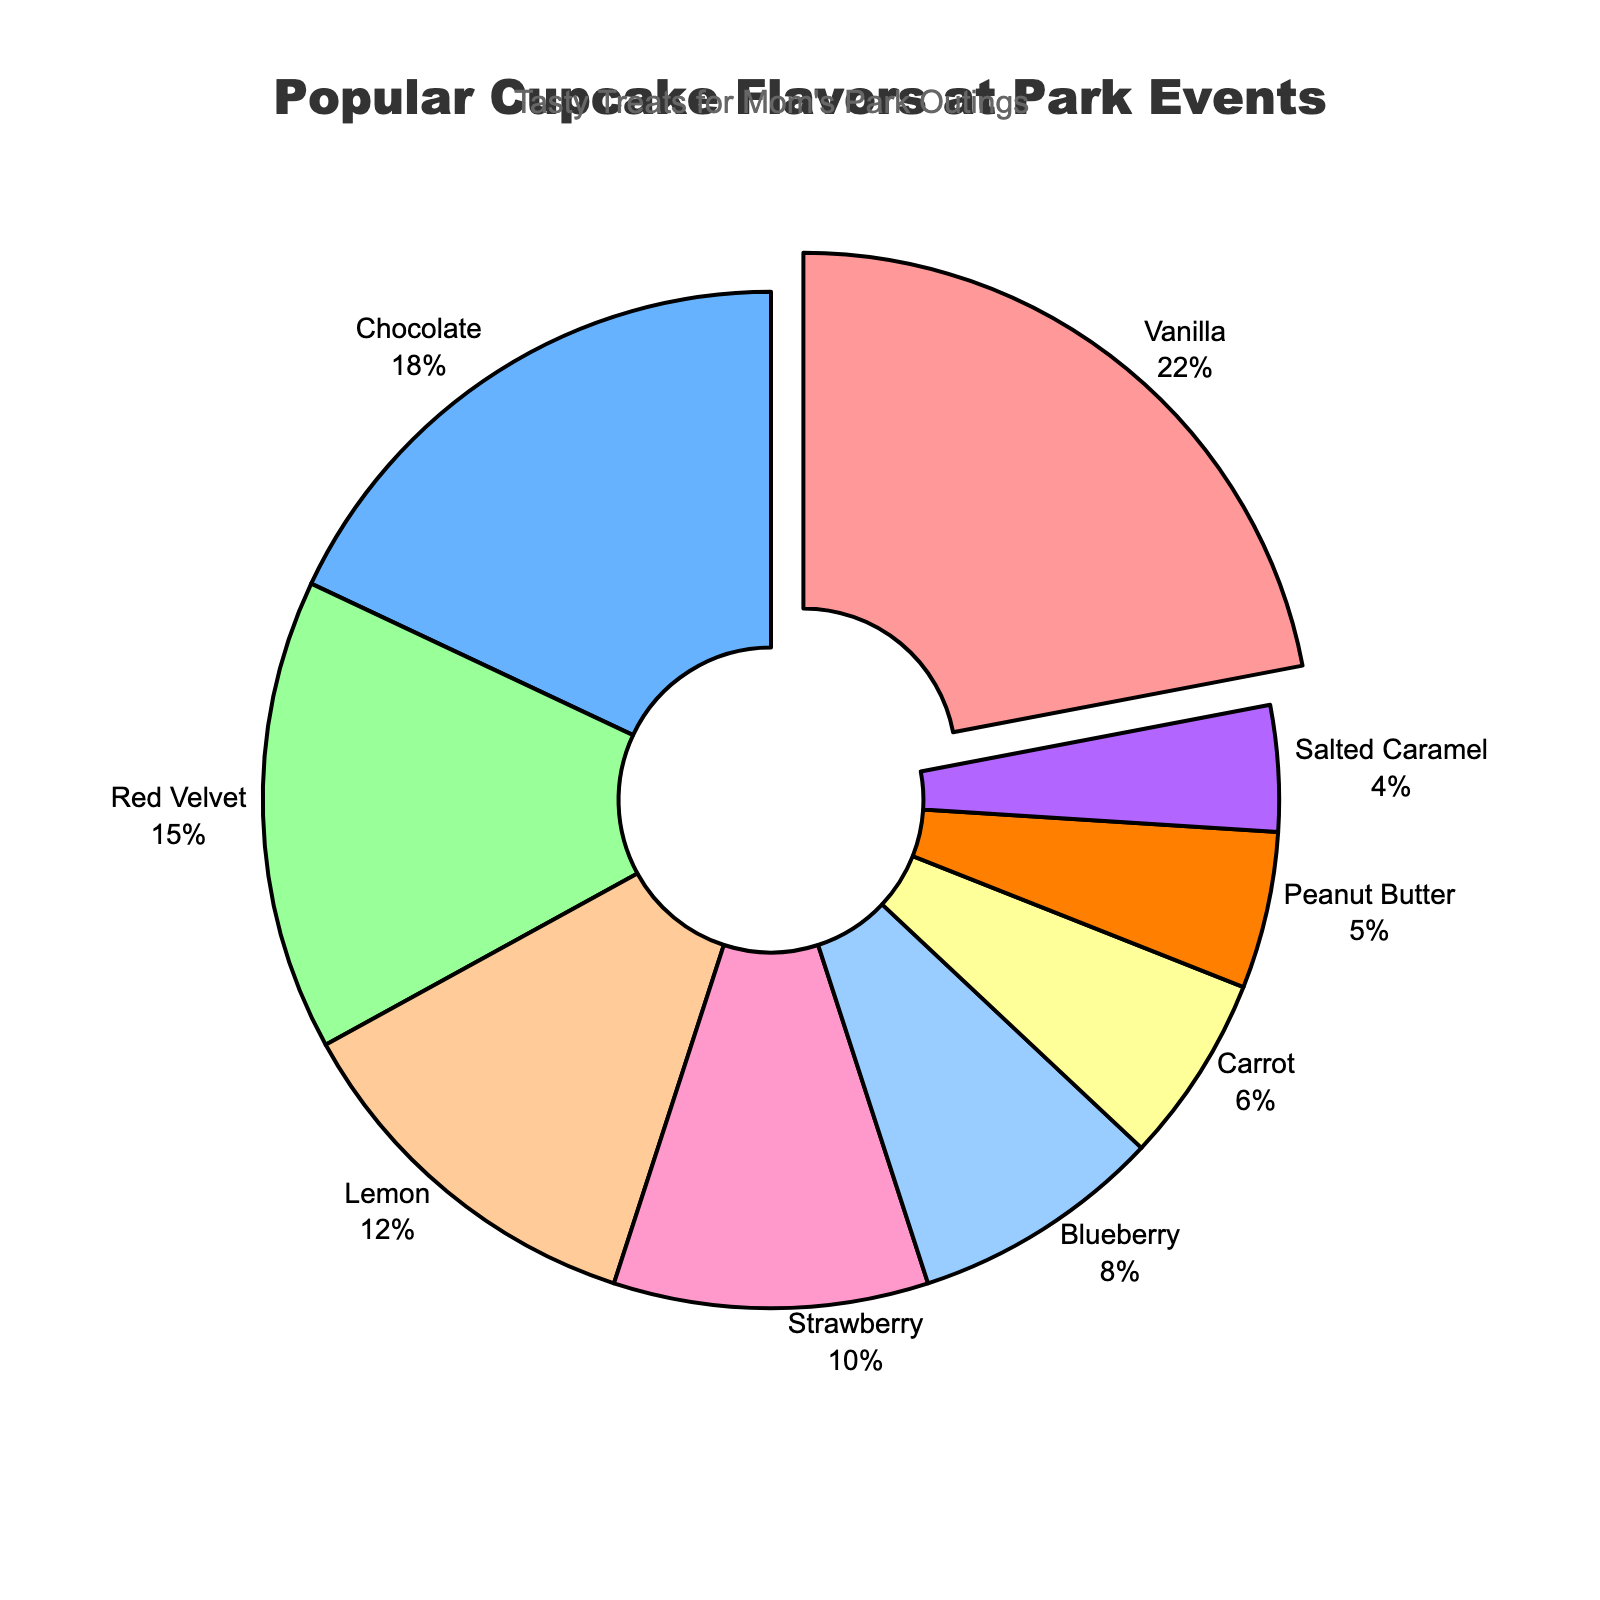What percentage of the cupcakes sold are Chocolate and Red Velvet combined? To find the combined percentage of Chocolate and Red Velvet cupcakes, add their individual percentages: 18% (Chocolate) + 15% (Red Velvet) = 33%.
Answer: 33% Which flavor is the least popular at park events? By looking at the percentages in the pie chart, the flavor with the smallest percentage is the least popular. Salted Caramel has the lowest percentage at 4%.
Answer: Salted Caramel What is the difference in percentage between the most popular flavor and the least popular flavor? To find the difference, subtract the smallest percentage from the largest percentage: 22% (Vanilla) - 4% (Salted Caramel) = 18%.
Answer: 18% How do Vanilla and Lemon compare in popularity? Vanilla has a 22% share, while Lemon has a 12% share. Since 22% is greater than 12%, Vanilla is more popular than Lemon.
Answer: Vanilla is more popular Which three flavors together make up over half of the cupcake sales? To find flavors that together surpass 50%, add the percentages of the most popular flavors until the sum exceeds 50%: 22% (Vanilla) + 18% (Chocolate) + 15% (Red Velvet) = 55%.
Answer: Vanilla, Chocolate, and Red Velvet If you combined the percentages of Lemon, Strawberry, and Blueberry, would they surpass the percentage of Vanilla? Combine Lemon's 12% + Strawberry's 10% + Blueberry's 8% = 30%. Since 30% is greater than Vanilla's 22%, these three flavors combined surpass Vanilla.
Answer: Yes What portion of the pie chart is occupied by the three least popular flavors? Sum the percentages of the three least popular flavors: 6% (Carrot) + 5% (Peanut Butter) + 4% (Salted Caramel) = 15%.
Answer: 15% Are there more fruit-based flavors (Strawberry, Lemon, Blueberry) or non-fruit-based flavors in the chart? Add the percentages of fruit-based flavors: 10% (Strawberry) + 12% (Lemon) + 8% (Blueberry) = 30%. Add the remaining non-fruit-based flavors: 22% (Vanilla) + 18% (Chocolate) + 15% (Red Velvet) + 6% (Carrot) + 5% (Peanut Butter) + 4% (Salted Caramel) = 70%. So, there are more non-fruit-based flavors.
Answer: More non-fruit-based flavors 